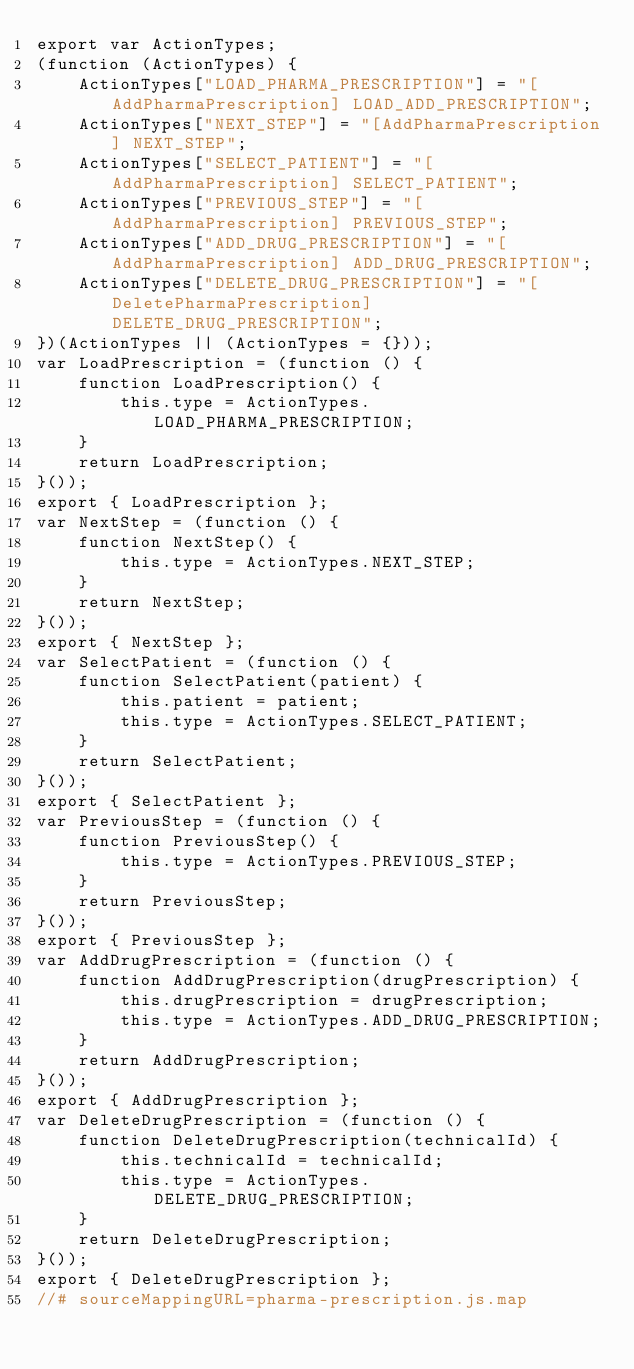Convert code to text. <code><loc_0><loc_0><loc_500><loc_500><_JavaScript_>export var ActionTypes;
(function (ActionTypes) {
    ActionTypes["LOAD_PHARMA_PRESCRIPTION"] = "[AddPharmaPrescription] LOAD_ADD_PRESCRIPTION";
    ActionTypes["NEXT_STEP"] = "[AddPharmaPrescription] NEXT_STEP";
    ActionTypes["SELECT_PATIENT"] = "[AddPharmaPrescription] SELECT_PATIENT";
    ActionTypes["PREVIOUS_STEP"] = "[AddPharmaPrescription] PREVIOUS_STEP";
    ActionTypes["ADD_DRUG_PRESCRIPTION"] = "[AddPharmaPrescription] ADD_DRUG_PRESCRIPTION";
    ActionTypes["DELETE_DRUG_PRESCRIPTION"] = "[DeletePharmaPrescription] DELETE_DRUG_PRESCRIPTION";
})(ActionTypes || (ActionTypes = {}));
var LoadPrescription = (function () {
    function LoadPrescription() {
        this.type = ActionTypes.LOAD_PHARMA_PRESCRIPTION;
    }
    return LoadPrescription;
}());
export { LoadPrescription };
var NextStep = (function () {
    function NextStep() {
        this.type = ActionTypes.NEXT_STEP;
    }
    return NextStep;
}());
export { NextStep };
var SelectPatient = (function () {
    function SelectPatient(patient) {
        this.patient = patient;
        this.type = ActionTypes.SELECT_PATIENT;
    }
    return SelectPatient;
}());
export { SelectPatient };
var PreviousStep = (function () {
    function PreviousStep() {
        this.type = ActionTypes.PREVIOUS_STEP;
    }
    return PreviousStep;
}());
export { PreviousStep };
var AddDrugPrescription = (function () {
    function AddDrugPrescription(drugPrescription) {
        this.drugPrescription = drugPrescription;
        this.type = ActionTypes.ADD_DRUG_PRESCRIPTION;
    }
    return AddDrugPrescription;
}());
export { AddDrugPrescription };
var DeleteDrugPrescription = (function () {
    function DeleteDrugPrescription(technicalId) {
        this.technicalId = technicalId;
        this.type = ActionTypes.DELETE_DRUG_PRESCRIPTION;
    }
    return DeleteDrugPrescription;
}());
export { DeleteDrugPrescription };
//# sourceMappingURL=pharma-prescription.js.map</code> 